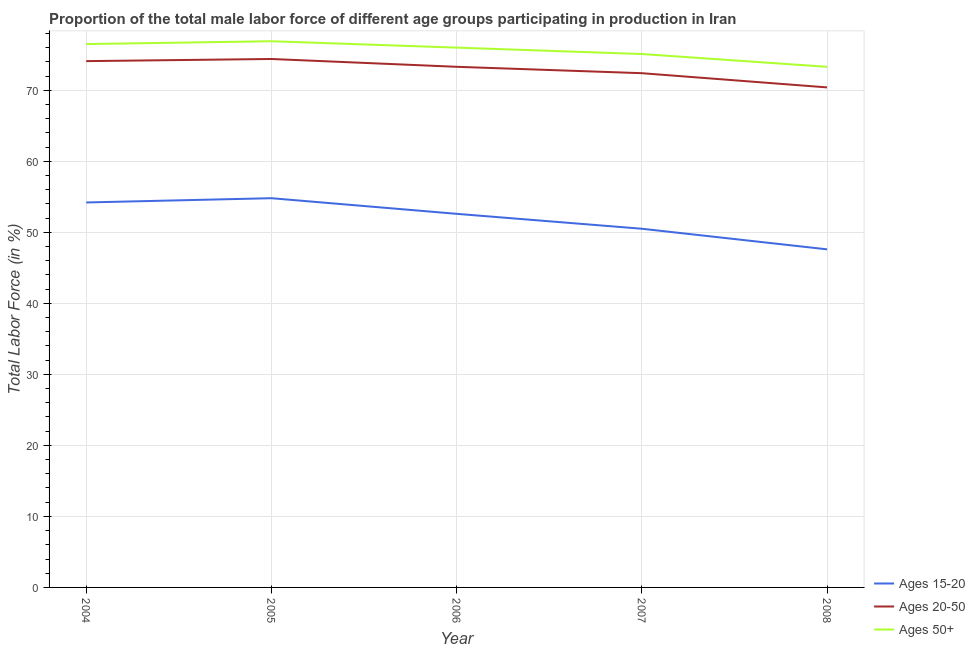Does the line corresponding to percentage of male labor force within the age group 15-20 intersect with the line corresponding to percentage of male labor force above age 50?
Keep it short and to the point. No. Is the number of lines equal to the number of legend labels?
Give a very brief answer. Yes. What is the percentage of male labor force above age 50 in 2004?
Offer a terse response. 76.5. Across all years, what is the maximum percentage of male labor force above age 50?
Your answer should be very brief. 76.9. Across all years, what is the minimum percentage of male labor force within the age group 20-50?
Provide a short and direct response. 70.4. In which year was the percentage of male labor force within the age group 15-20 maximum?
Your answer should be very brief. 2005. What is the total percentage of male labor force within the age group 20-50 in the graph?
Provide a succinct answer. 364.6. What is the difference between the percentage of male labor force within the age group 20-50 in 2006 and that in 2008?
Ensure brevity in your answer.  2.9. What is the difference between the percentage of male labor force above age 50 in 2007 and the percentage of male labor force within the age group 20-50 in 2005?
Offer a very short reply. 0.7. What is the average percentage of male labor force above age 50 per year?
Your response must be concise. 75.56. In the year 2006, what is the difference between the percentage of male labor force within the age group 15-20 and percentage of male labor force above age 50?
Ensure brevity in your answer.  -23.4. What is the ratio of the percentage of male labor force within the age group 15-20 in 2005 to that in 2007?
Ensure brevity in your answer.  1.09. Is the percentage of male labor force within the age group 20-50 in 2004 less than that in 2008?
Your response must be concise. No. Is the difference between the percentage of male labor force within the age group 15-20 in 2004 and 2005 greater than the difference between the percentage of male labor force within the age group 20-50 in 2004 and 2005?
Provide a succinct answer. No. What is the difference between the highest and the second highest percentage of male labor force above age 50?
Make the answer very short. 0.4. What is the difference between the highest and the lowest percentage of male labor force above age 50?
Your response must be concise. 3.6. Is the sum of the percentage of male labor force above age 50 in 2004 and 2005 greater than the maximum percentage of male labor force within the age group 15-20 across all years?
Your answer should be very brief. Yes. Does the percentage of male labor force within the age group 20-50 monotonically increase over the years?
Offer a very short reply. No. Is the percentage of male labor force above age 50 strictly greater than the percentage of male labor force within the age group 20-50 over the years?
Your answer should be very brief. Yes. Is the percentage of male labor force within the age group 20-50 strictly less than the percentage of male labor force above age 50 over the years?
Your response must be concise. Yes. What is the difference between two consecutive major ticks on the Y-axis?
Your answer should be compact. 10. Are the values on the major ticks of Y-axis written in scientific E-notation?
Keep it short and to the point. No. Does the graph contain grids?
Offer a terse response. Yes. How are the legend labels stacked?
Ensure brevity in your answer.  Vertical. What is the title of the graph?
Provide a succinct answer. Proportion of the total male labor force of different age groups participating in production in Iran. Does "Hydroelectric sources" appear as one of the legend labels in the graph?
Provide a short and direct response. No. What is the Total Labor Force (in %) of Ages 15-20 in 2004?
Your answer should be very brief. 54.2. What is the Total Labor Force (in %) in Ages 20-50 in 2004?
Keep it short and to the point. 74.1. What is the Total Labor Force (in %) in Ages 50+ in 2004?
Keep it short and to the point. 76.5. What is the Total Labor Force (in %) in Ages 15-20 in 2005?
Provide a succinct answer. 54.8. What is the Total Labor Force (in %) in Ages 20-50 in 2005?
Provide a succinct answer. 74.4. What is the Total Labor Force (in %) in Ages 50+ in 2005?
Your response must be concise. 76.9. What is the Total Labor Force (in %) of Ages 15-20 in 2006?
Make the answer very short. 52.6. What is the Total Labor Force (in %) in Ages 20-50 in 2006?
Give a very brief answer. 73.3. What is the Total Labor Force (in %) in Ages 15-20 in 2007?
Your answer should be very brief. 50.5. What is the Total Labor Force (in %) of Ages 20-50 in 2007?
Offer a very short reply. 72.4. What is the Total Labor Force (in %) in Ages 50+ in 2007?
Ensure brevity in your answer.  75.1. What is the Total Labor Force (in %) of Ages 15-20 in 2008?
Your answer should be very brief. 47.6. What is the Total Labor Force (in %) in Ages 20-50 in 2008?
Offer a terse response. 70.4. What is the Total Labor Force (in %) of Ages 50+ in 2008?
Your answer should be compact. 73.3. Across all years, what is the maximum Total Labor Force (in %) in Ages 15-20?
Provide a succinct answer. 54.8. Across all years, what is the maximum Total Labor Force (in %) of Ages 20-50?
Ensure brevity in your answer.  74.4. Across all years, what is the maximum Total Labor Force (in %) of Ages 50+?
Keep it short and to the point. 76.9. Across all years, what is the minimum Total Labor Force (in %) in Ages 15-20?
Ensure brevity in your answer.  47.6. Across all years, what is the minimum Total Labor Force (in %) in Ages 20-50?
Give a very brief answer. 70.4. Across all years, what is the minimum Total Labor Force (in %) in Ages 50+?
Give a very brief answer. 73.3. What is the total Total Labor Force (in %) of Ages 15-20 in the graph?
Make the answer very short. 259.7. What is the total Total Labor Force (in %) in Ages 20-50 in the graph?
Offer a terse response. 364.6. What is the total Total Labor Force (in %) in Ages 50+ in the graph?
Make the answer very short. 377.8. What is the difference between the Total Labor Force (in %) of Ages 15-20 in 2004 and that in 2005?
Offer a terse response. -0.6. What is the difference between the Total Labor Force (in %) of Ages 20-50 in 2004 and that in 2005?
Your response must be concise. -0.3. What is the difference between the Total Labor Force (in %) in Ages 15-20 in 2004 and that in 2006?
Your answer should be very brief. 1.6. What is the difference between the Total Labor Force (in %) in Ages 20-50 in 2004 and that in 2006?
Your response must be concise. 0.8. What is the difference between the Total Labor Force (in %) in Ages 20-50 in 2004 and that in 2007?
Offer a very short reply. 1.7. What is the difference between the Total Labor Force (in %) in Ages 50+ in 2004 and that in 2007?
Ensure brevity in your answer.  1.4. What is the difference between the Total Labor Force (in %) of Ages 50+ in 2004 and that in 2008?
Provide a succinct answer. 3.2. What is the difference between the Total Labor Force (in %) of Ages 20-50 in 2005 and that in 2006?
Make the answer very short. 1.1. What is the difference between the Total Labor Force (in %) of Ages 50+ in 2005 and that in 2006?
Provide a short and direct response. 0.9. What is the difference between the Total Labor Force (in %) of Ages 20-50 in 2005 and that in 2007?
Your response must be concise. 2. What is the difference between the Total Labor Force (in %) of Ages 15-20 in 2005 and that in 2008?
Offer a terse response. 7.2. What is the difference between the Total Labor Force (in %) in Ages 20-50 in 2005 and that in 2008?
Your answer should be very brief. 4. What is the difference between the Total Labor Force (in %) in Ages 15-20 in 2006 and that in 2007?
Ensure brevity in your answer.  2.1. What is the difference between the Total Labor Force (in %) of Ages 50+ in 2006 and that in 2007?
Your answer should be very brief. 0.9. What is the difference between the Total Labor Force (in %) in Ages 50+ in 2006 and that in 2008?
Offer a very short reply. 2.7. What is the difference between the Total Labor Force (in %) in Ages 15-20 in 2007 and that in 2008?
Ensure brevity in your answer.  2.9. What is the difference between the Total Labor Force (in %) of Ages 50+ in 2007 and that in 2008?
Your answer should be compact. 1.8. What is the difference between the Total Labor Force (in %) of Ages 15-20 in 2004 and the Total Labor Force (in %) of Ages 20-50 in 2005?
Make the answer very short. -20.2. What is the difference between the Total Labor Force (in %) in Ages 15-20 in 2004 and the Total Labor Force (in %) in Ages 50+ in 2005?
Your answer should be compact. -22.7. What is the difference between the Total Labor Force (in %) of Ages 15-20 in 2004 and the Total Labor Force (in %) of Ages 20-50 in 2006?
Make the answer very short. -19.1. What is the difference between the Total Labor Force (in %) of Ages 15-20 in 2004 and the Total Labor Force (in %) of Ages 50+ in 2006?
Your answer should be compact. -21.8. What is the difference between the Total Labor Force (in %) in Ages 15-20 in 2004 and the Total Labor Force (in %) in Ages 20-50 in 2007?
Your answer should be very brief. -18.2. What is the difference between the Total Labor Force (in %) of Ages 15-20 in 2004 and the Total Labor Force (in %) of Ages 50+ in 2007?
Your answer should be very brief. -20.9. What is the difference between the Total Labor Force (in %) in Ages 15-20 in 2004 and the Total Labor Force (in %) in Ages 20-50 in 2008?
Your answer should be very brief. -16.2. What is the difference between the Total Labor Force (in %) of Ages 15-20 in 2004 and the Total Labor Force (in %) of Ages 50+ in 2008?
Offer a terse response. -19.1. What is the difference between the Total Labor Force (in %) of Ages 20-50 in 2004 and the Total Labor Force (in %) of Ages 50+ in 2008?
Keep it short and to the point. 0.8. What is the difference between the Total Labor Force (in %) in Ages 15-20 in 2005 and the Total Labor Force (in %) in Ages 20-50 in 2006?
Provide a succinct answer. -18.5. What is the difference between the Total Labor Force (in %) in Ages 15-20 in 2005 and the Total Labor Force (in %) in Ages 50+ in 2006?
Your answer should be very brief. -21.2. What is the difference between the Total Labor Force (in %) of Ages 20-50 in 2005 and the Total Labor Force (in %) of Ages 50+ in 2006?
Give a very brief answer. -1.6. What is the difference between the Total Labor Force (in %) of Ages 15-20 in 2005 and the Total Labor Force (in %) of Ages 20-50 in 2007?
Provide a short and direct response. -17.6. What is the difference between the Total Labor Force (in %) in Ages 15-20 in 2005 and the Total Labor Force (in %) in Ages 50+ in 2007?
Provide a short and direct response. -20.3. What is the difference between the Total Labor Force (in %) of Ages 20-50 in 2005 and the Total Labor Force (in %) of Ages 50+ in 2007?
Keep it short and to the point. -0.7. What is the difference between the Total Labor Force (in %) in Ages 15-20 in 2005 and the Total Labor Force (in %) in Ages 20-50 in 2008?
Keep it short and to the point. -15.6. What is the difference between the Total Labor Force (in %) of Ages 15-20 in 2005 and the Total Labor Force (in %) of Ages 50+ in 2008?
Give a very brief answer. -18.5. What is the difference between the Total Labor Force (in %) in Ages 15-20 in 2006 and the Total Labor Force (in %) in Ages 20-50 in 2007?
Ensure brevity in your answer.  -19.8. What is the difference between the Total Labor Force (in %) in Ages 15-20 in 2006 and the Total Labor Force (in %) in Ages 50+ in 2007?
Provide a succinct answer. -22.5. What is the difference between the Total Labor Force (in %) of Ages 15-20 in 2006 and the Total Labor Force (in %) of Ages 20-50 in 2008?
Make the answer very short. -17.8. What is the difference between the Total Labor Force (in %) of Ages 15-20 in 2006 and the Total Labor Force (in %) of Ages 50+ in 2008?
Ensure brevity in your answer.  -20.7. What is the difference between the Total Labor Force (in %) of Ages 20-50 in 2006 and the Total Labor Force (in %) of Ages 50+ in 2008?
Ensure brevity in your answer.  0. What is the difference between the Total Labor Force (in %) in Ages 15-20 in 2007 and the Total Labor Force (in %) in Ages 20-50 in 2008?
Keep it short and to the point. -19.9. What is the difference between the Total Labor Force (in %) of Ages 15-20 in 2007 and the Total Labor Force (in %) of Ages 50+ in 2008?
Your answer should be very brief. -22.8. What is the average Total Labor Force (in %) of Ages 15-20 per year?
Ensure brevity in your answer.  51.94. What is the average Total Labor Force (in %) of Ages 20-50 per year?
Your answer should be very brief. 72.92. What is the average Total Labor Force (in %) of Ages 50+ per year?
Your response must be concise. 75.56. In the year 2004, what is the difference between the Total Labor Force (in %) of Ages 15-20 and Total Labor Force (in %) of Ages 20-50?
Make the answer very short. -19.9. In the year 2004, what is the difference between the Total Labor Force (in %) of Ages 15-20 and Total Labor Force (in %) of Ages 50+?
Your response must be concise. -22.3. In the year 2004, what is the difference between the Total Labor Force (in %) in Ages 20-50 and Total Labor Force (in %) in Ages 50+?
Make the answer very short. -2.4. In the year 2005, what is the difference between the Total Labor Force (in %) of Ages 15-20 and Total Labor Force (in %) of Ages 20-50?
Offer a very short reply. -19.6. In the year 2005, what is the difference between the Total Labor Force (in %) of Ages 15-20 and Total Labor Force (in %) of Ages 50+?
Offer a very short reply. -22.1. In the year 2006, what is the difference between the Total Labor Force (in %) of Ages 15-20 and Total Labor Force (in %) of Ages 20-50?
Provide a succinct answer. -20.7. In the year 2006, what is the difference between the Total Labor Force (in %) of Ages 15-20 and Total Labor Force (in %) of Ages 50+?
Offer a very short reply. -23.4. In the year 2007, what is the difference between the Total Labor Force (in %) of Ages 15-20 and Total Labor Force (in %) of Ages 20-50?
Your answer should be very brief. -21.9. In the year 2007, what is the difference between the Total Labor Force (in %) of Ages 15-20 and Total Labor Force (in %) of Ages 50+?
Your response must be concise. -24.6. In the year 2007, what is the difference between the Total Labor Force (in %) of Ages 20-50 and Total Labor Force (in %) of Ages 50+?
Your answer should be compact. -2.7. In the year 2008, what is the difference between the Total Labor Force (in %) of Ages 15-20 and Total Labor Force (in %) of Ages 20-50?
Keep it short and to the point. -22.8. In the year 2008, what is the difference between the Total Labor Force (in %) of Ages 15-20 and Total Labor Force (in %) of Ages 50+?
Keep it short and to the point. -25.7. In the year 2008, what is the difference between the Total Labor Force (in %) of Ages 20-50 and Total Labor Force (in %) of Ages 50+?
Ensure brevity in your answer.  -2.9. What is the ratio of the Total Labor Force (in %) of Ages 20-50 in 2004 to that in 2005?
Provide a succinct answer. 1. What is the ratio of the Total Labor Force (in %) of Ages 50+ in 2004 to that in 2005?
Your answer should be compact. 0.99. What is the ratio of the Total Labor Force (in %) of Ages 15-20 in 2004 to that in 2006?
Keep it short and to the point. 1.03. What is the ratio of the Total Labor Force (in %) of Ages 20-50 in 2004 to that in 2006?
Offer a very short reply. 1.01. What is the ratio of the Total Labor Force (in %) of Ages 50+ in 2004 to that in 2006?
Offer a very short reply. 1.01. What is the ratio of the Total Labor Force (in %) in Ages 15-20 in 2004 to that in 2007?
Keep it short and to the point. 1.07. What is the ratio of the Total Labor Force (in %) in Ages 20-50 in 2004 to that in 2007?
Provide a short and direct response. 1.02. What is the ratio of the Total Labor Force (in %) of Ages 50+ in 2004 to that in 2007?
Offer a very short reply. 1.02. What is the ratio of the Total Labor Force (in %) of Ages 15-20 in 2004 to that in 2008?
Your answer should be very brief. 1.14. What is the ratio of the Total Labor Force (in %) of Ages 20-50 in 2004 to that in 2008?
Your answer should be compact. 1.05. What is the ratio of the Total Labor Force (in %) of Ages 50+ in 2004 to that in 2008?
Provide a short and direct response. 1.04. What is the ratio of the Total Labor Force (in %) in Ages 15-20 in 2005 to that in 2006?
Keep it short and to the point. 1.04. What is the ratio of the Total Labor Force (in %) in Ages 20-50 in 2005 to that in 2006?
Keep it short and to the point. 1.01. What is the ratio of the Total Labor Force (in %) of Ages 50+ in 2005 to that in 2006?
Provide a short and direct response. 1.01. What is the ratio of the Total Labor Force (in %) of Ages 15-20 in 2005 to that in 2007?
Ensure brevity in your answer.  1.09. What is the ratio of the Total Labor Force (in %) of Ages 20-50 in 2005 to that in 2007?
Make the answer very short. 1.03. What is the ratio of the Total Labor Force (in %) in Ages 50+ in 2005 to that in 2007?
Your answer should be compact. 1.02. What is the ratio of the Total Labor Force (in %) in Ages 15-20 in 2005 to that in 2008?
Your response must be concise. 1.15. What is the ratio of the Total Labor Force (in %) in Ages 20-50 in 2005 to that in 2008?
Offer a very short reply. 1.06. What is the ratio of the Total Labor Force (in %) in Ages 50+ in 2005 to that in 2008?
Keep it short and to the point. 1.05. What is the ratio of the Total Labor Force (in %) of Ages 15-20 in 2006 to that in 2007?
Provide a short and direct response. 1.04. What is the ratio of the Total Labor Force (in %) in Ages 20-50 in 2006 to that in 2007?
Ensure brevity in your answer.  1.01. What is the ratio of the Total Labor Force (in %) in Ages 15-20 in 2006 to that in 2008?
Your answer should be very brief. 1.1. What is the ratio of the Total Labor Force (in %) in Ages 20-50 in 2006 to that in 2008?
Offer a terse response. 1.04. What is the ratio of the Total Labor Force (in %) of Ages 50+ in 2006 to that in 2008?
Your response must be concise. 1.04. What is the ratio of the Total Labor Force (in %) in Ages 15-20 in 2007 to that in 2008?
Make the answer very short. 1.06. What is the ratio of the Total Labor Force (in %) in Ages 20-50 in 2007 to that in 2008?
Offer a very short reply. 1.03. What is the ratio of the Total Labor Force (in %) of Ages 50+ in 2007 to that in 2008?
Keep it short and to the point. 1.02. What is the difference between the highest and the second highest Total Labor Force (in %) of Ages 50+?
Ensure brevity in your answer.  0.4. What is the difference between the highest and the lowest Total Labor Force (in %) in Ages 20-50?
Give a very brief answer. 4. 